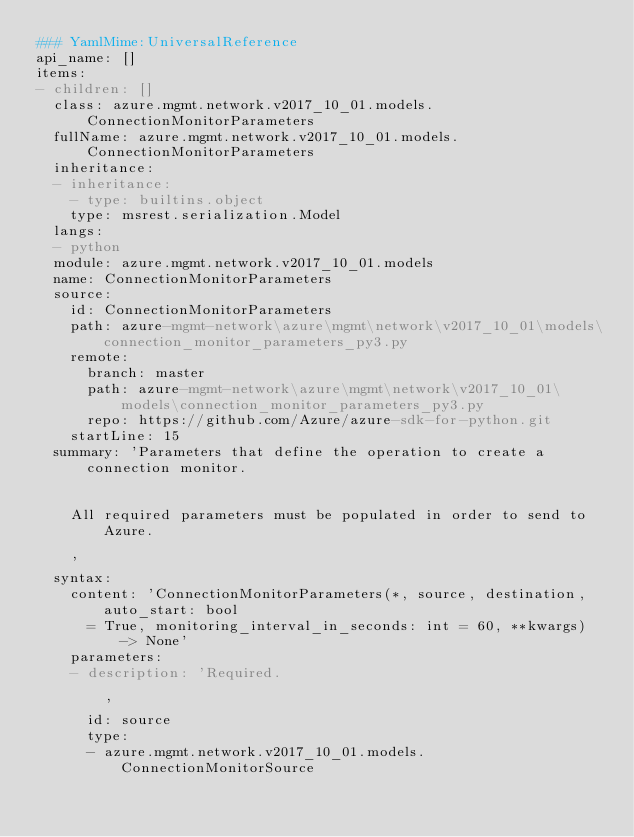<code> <loc_0><loc_0><loc_500><loc_500><_YAML_>### YamlMime:UniversalReference
api_name: []
items:
- children: []
  class: azure.mgmt.network.v2017_10_01.models.ConnectionMonitorParameters
  fullName: azure.mgmt.network.v2017_10_01.models.ConnectionMonitorParameters
  inheritance:
  - inheritance:
    - type: builtins.object
    type: msrest.serialization.Model
  langs:
  - python
  module: azure.mgmt.network.v2017_10_01.models
  name: ConnectionMonitorParameters
  source:
    id: ConnectionMonitorParameters
    path: azure-mgmt-network\azure\mgmt\network\v2017_10_01\models\connection_monitor_parameters_py3.py
    remote:
      branch: master
      path: azure-mgmt-network\azure\mgmt\network\v2017_10_01\models\connection_monitor_parameters_py3.py
      repo: https://github.com/Azure/azure-sdk-for-python.git
    startLine: 15
  summary: 'Parameters that define the operation to create a connection monitor.


    All required parameters must be populated in order to send to Azure.

    '
  syntax:
    content: 'ConnectionMonitorParameters(*, source, destination, auto_start: bool
      = True, monitoring_interval_in_seconds: int = 60, **kwargs) -> None'
    parameters:
    - description: 'Required.

        '
      id: source
      type:
      - azure.mgmt.network.v2017_10_01.models.ConnectionMonitorSource</code> 